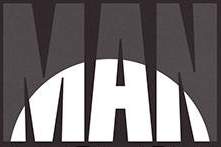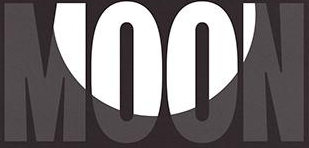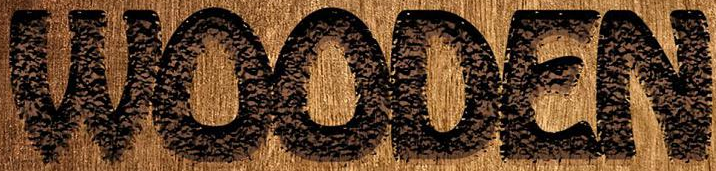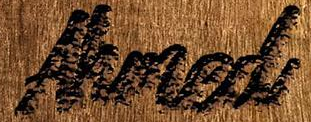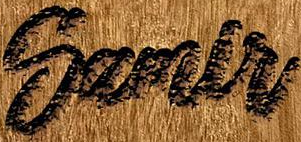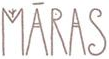What text appears in these images from left to right, separated by a semicolon? MAN; MOON; WOODEN; Ahmed; Samlr; MĀRAS 